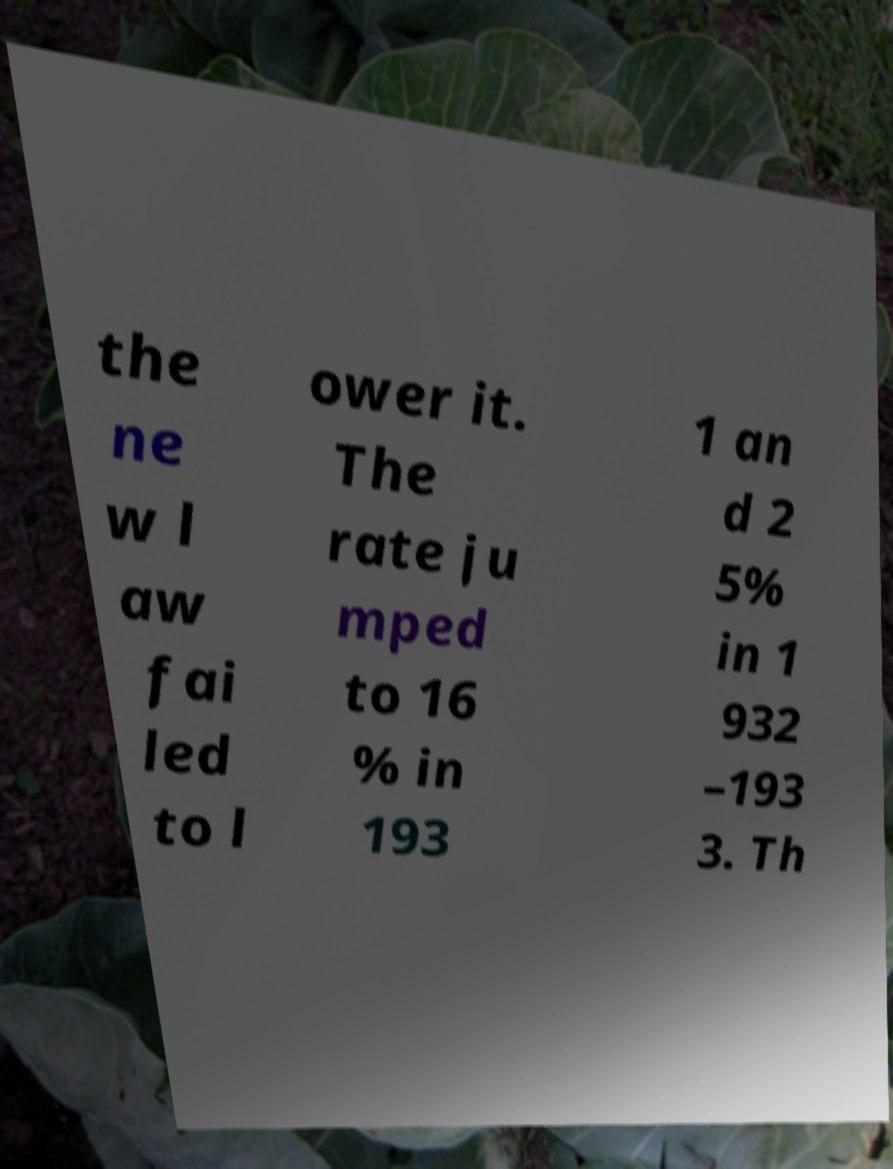Can you accurately transcribe the text from the provided image for me? the ne w l aw fai led to l ower it. The rate ju mped to 16 % in 193 1 an d 2 5% in 1 932 –193 3. Th 